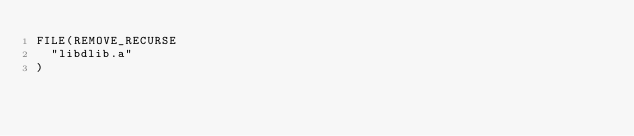<code> <loc_0><loc_0><loc_500><loc_500><_CMake_>FILE(REMOVE_RECURSE
  "libdlib.a"
)
</code> 